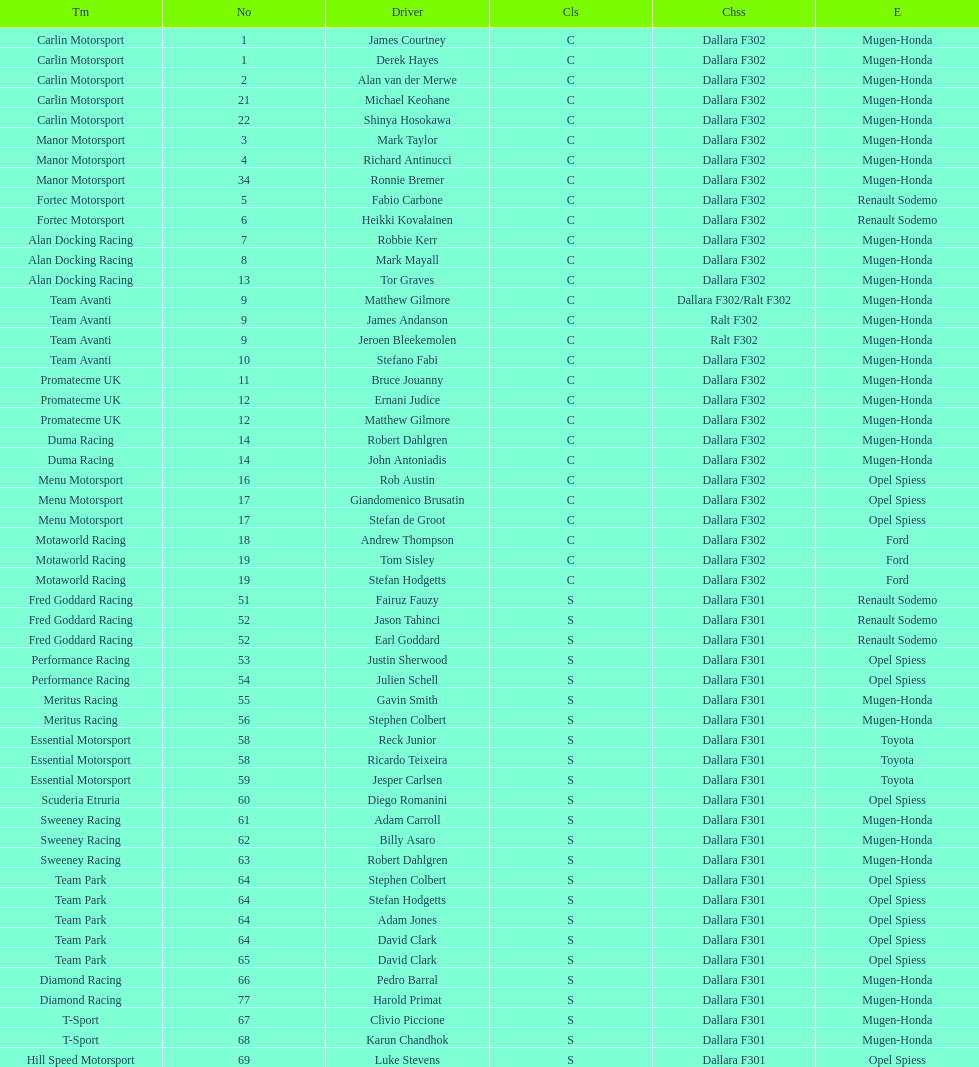Along with clivio piccione, who is the second driver for t-sport? Karun Chandhok. 